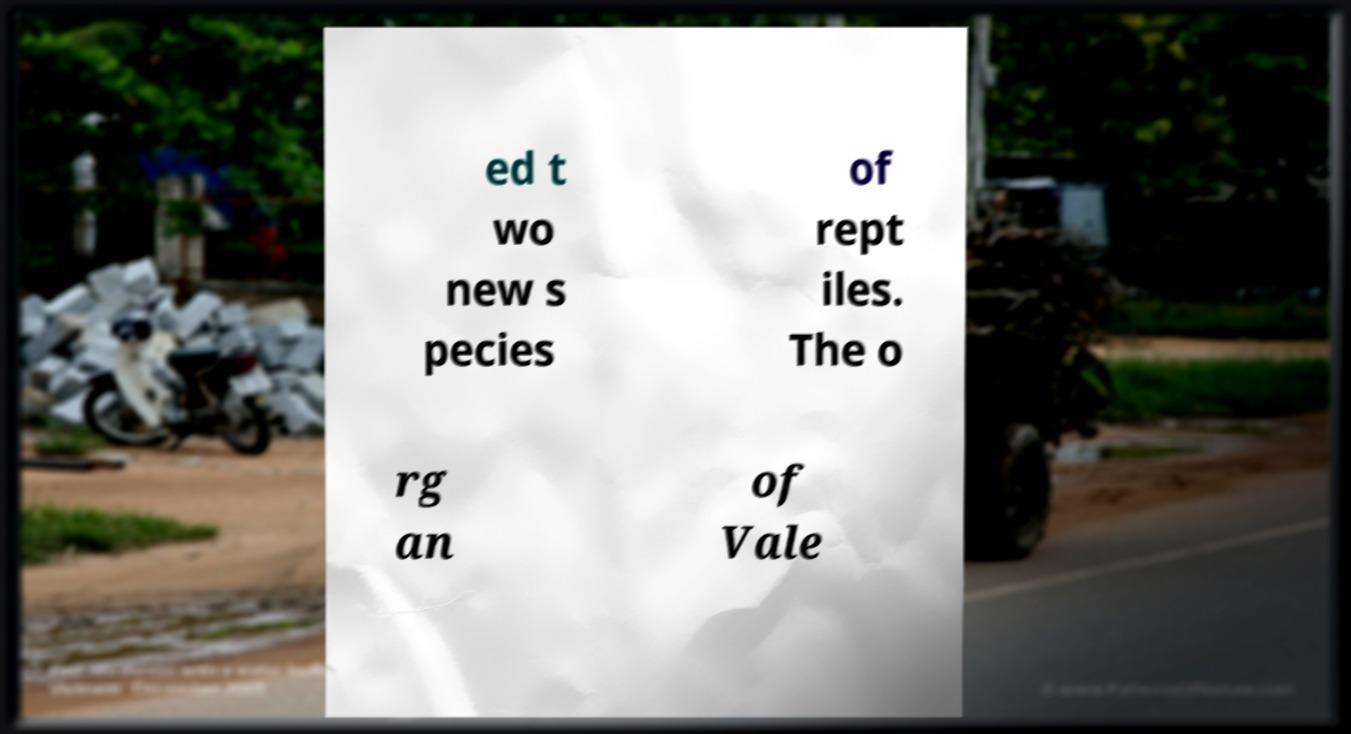Can you read and provide the text displayed in the image?This photo seems to have some interesting text. Can you extract and type it out for me? ed t wo new s pecies of rept iles. The o rg an of Vale 